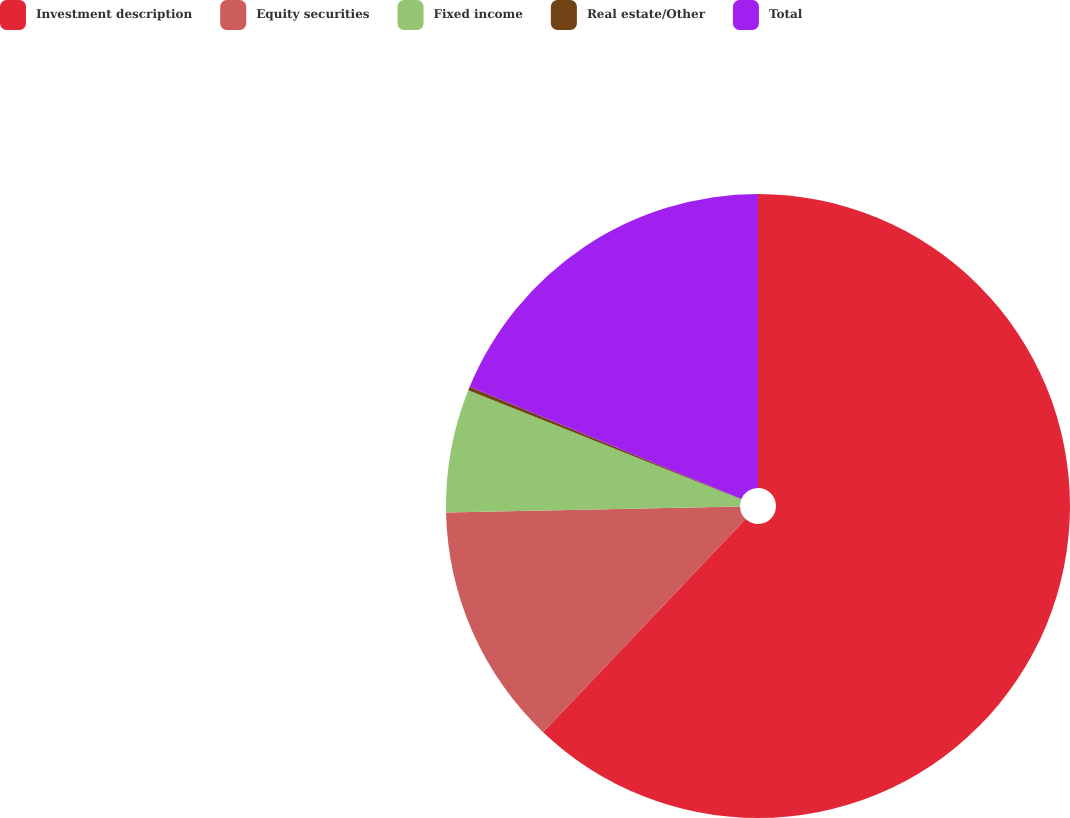Convert chart to OTSL. <chart><loc_0><loc_0><loc_500><loc_500><pie_chart><fcel>Investment description<fcel>Equity securities<fcel>Fixed income<fcel>Real estate/Other<fcel>Total<nl><fcel>62.09%<fcel>12.57%<fcel>6.38%<fcel>0.19%<fcel>18.76%<nl></chart> 